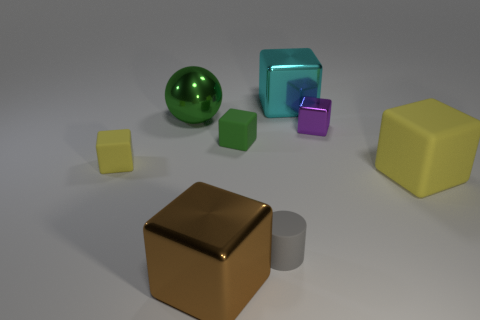There is a rubber object that is the same color as the ball; what is its shape?
Your response must be concise. Cube. What size is the rubber block that is the same color as the metallic ball?
Offer a very short reply. Small. There is a thing that is the same color as the shiny ball; what is its material?
Offer a terse response. Rubber. What shape is the yellow thing that is on the left side of the large metallic block behind the gray rubber thing behind the brown object?
Your answer should be very brief. Cube. What shape is the big object that is behind the big yellow object and to the right of the ball?
Ensure brevity in your answer.  Cube. There is a big green thing that is behind the small matte thing that is behind the tiny yellow matte block; how many tiny objects are on the right side of it?
Give a very brief answer. 3. What size is the green object that is the same shape as the purple object?
Offer a terse response. Small. Is there any other thing that has the same size as the rubber cylinder?
Your response must be concise. Yes. Does the yellow object that is to the right of the small gray rubber thing have the same material as the cyan thing?
Your answer should be very brief. No. The big rubber thing that is the same shape as the small purple thing is what color?
Provide a short and direct response. Yellow. 